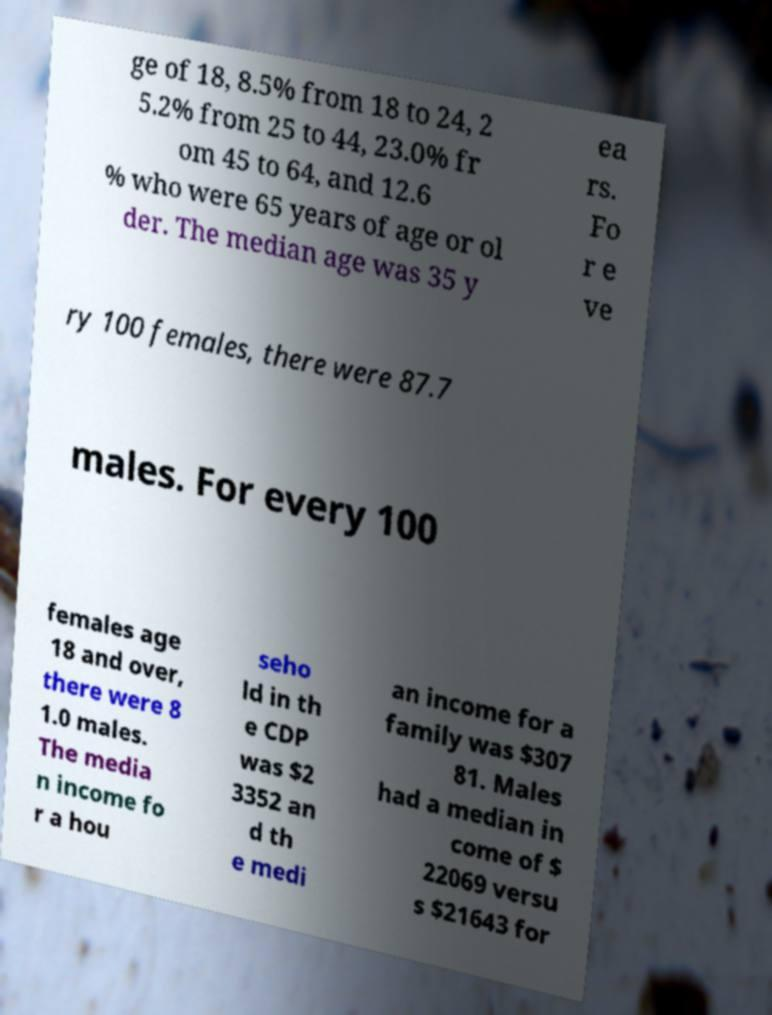What messages or text are displayed in this image? I need them in a readable, typed format. ge of 18, 8.5% from 18 to 24, 2 5.2% from 25 to 44, 23.0% fr om 45 to 64, and 12.6 % who were 65 years of age or ol der. The median age was 35 y ea rs. Fo r e ve ry 100 females, there were 87.7 males. For every 100 females age 18 and over, there were 8 1.0 males. The media n income fo r a hou seho ld in th e CDP was $2 3352 an d th e medi an income for a family was $307 81. Males had a median in come of $ 22069 versu s $21643 for 